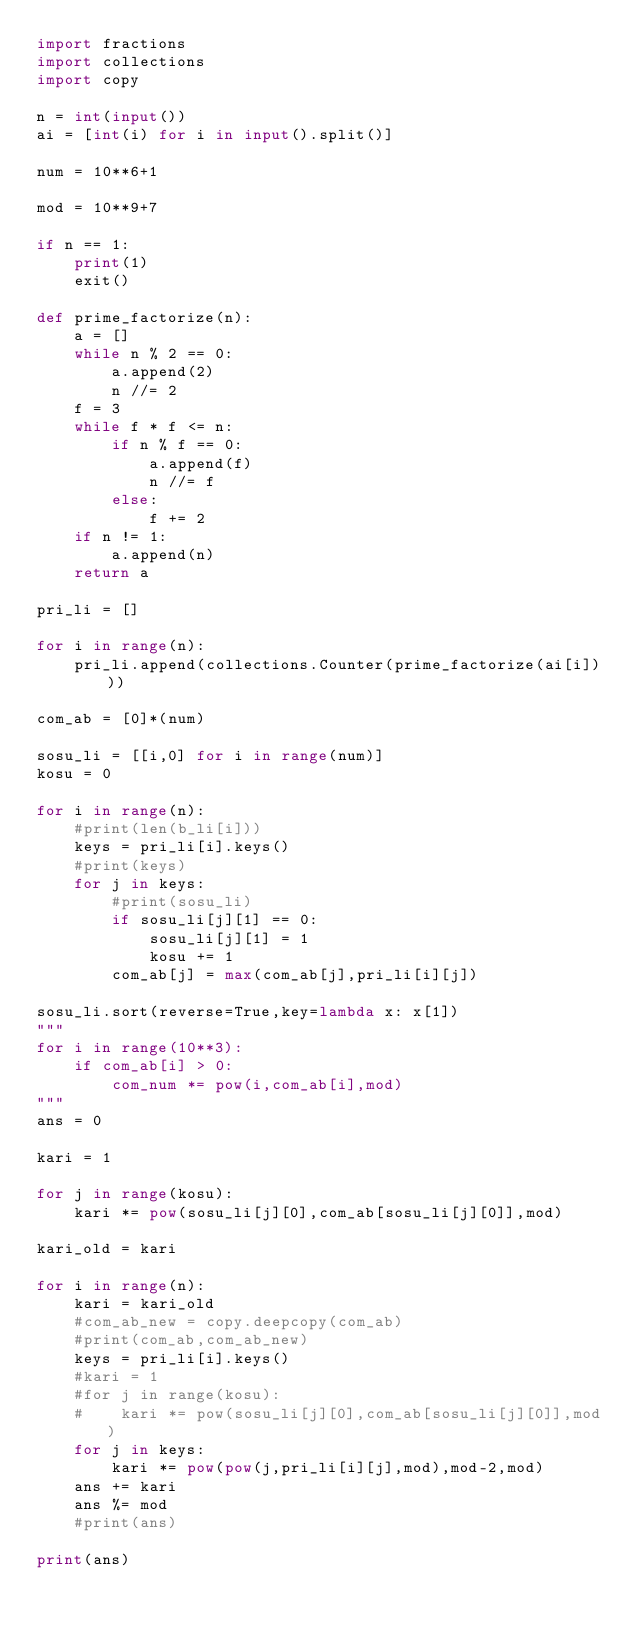<code> <loc_0><loc_0><loc_500><loc_500><_Python_>import fractions
import collections
import copy

n = int(input())
ai = [int(i) for i in input().split()]

num = 10**6+1

mod = 10**9+7

if n == 1:
    print(1)
    exit()

def prime_factorize(n):
    a = []
    while n % 2 == 0:
        a.append(2)
        n //= 2
    f = 3
    while f * f <= n:
        if n % f == 0:
            a.append(f)
            n //= f
        else:
            f += 2
    if n != 1:
        a.append(n)
    return a

pri_li = []

for i in range(n):
    pri_li.append(collections.Counter(prime_factorize(ai[i])))

com_ab = [0]*(num)

sosu_li = [[i,0] for i in range(num)]
kosu = 0

for i in range(n):
    #print(len(b_li[i]))
    keys = pri_li[i].keys()
    #print(keys)
    for j in keys:
        #print(sosu_li)
        if sosu_li[j][1] == 0:
            sosu_li[j][1] = 1
            kosu += 1
        com_ab[j] = max(com_ab[j],pri_li[i][j])

sosu_li.sort(reverse=True,key=lambda x: x[1])
"""
for i in range(10**3):
    if com_ab[i] > 0:
        com_num *= pow(i,com_ab[i],mod)
"""
ans = 0

kari = 1

for j in range(kosu):
    kari *= pow(sosu_li[j][0],com_ab[sosu_li[j][0]],mod)

kari_old = kari

for i in range(n):
    kari = kari_old
    #com_ab_new = copy.deepcopy(com_ab)
    #print(com_ab,com_ab_new)
    keys = pri_li[i].keys()
    #kari = 1
    #for j in range(kosu):
    #    kari *= pow(sosu_li[j][0],com_ab[sosu_li[j][0]],mod)
    for j in keys:
        kari *= pow(pow(j,pri_li[i][j],mod),mod-2,mod)
    ans += kari
    ans %= mod
    #print(ans)
        
print(ans)
</code> 